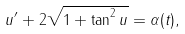<formula> <loc_0><loc_0><loc_500><loc_500>u ^ { \prime } + 2 \sqrt { 1 + \tan ^ { 2 } u } = \alpha ( t ) ,</formula> 